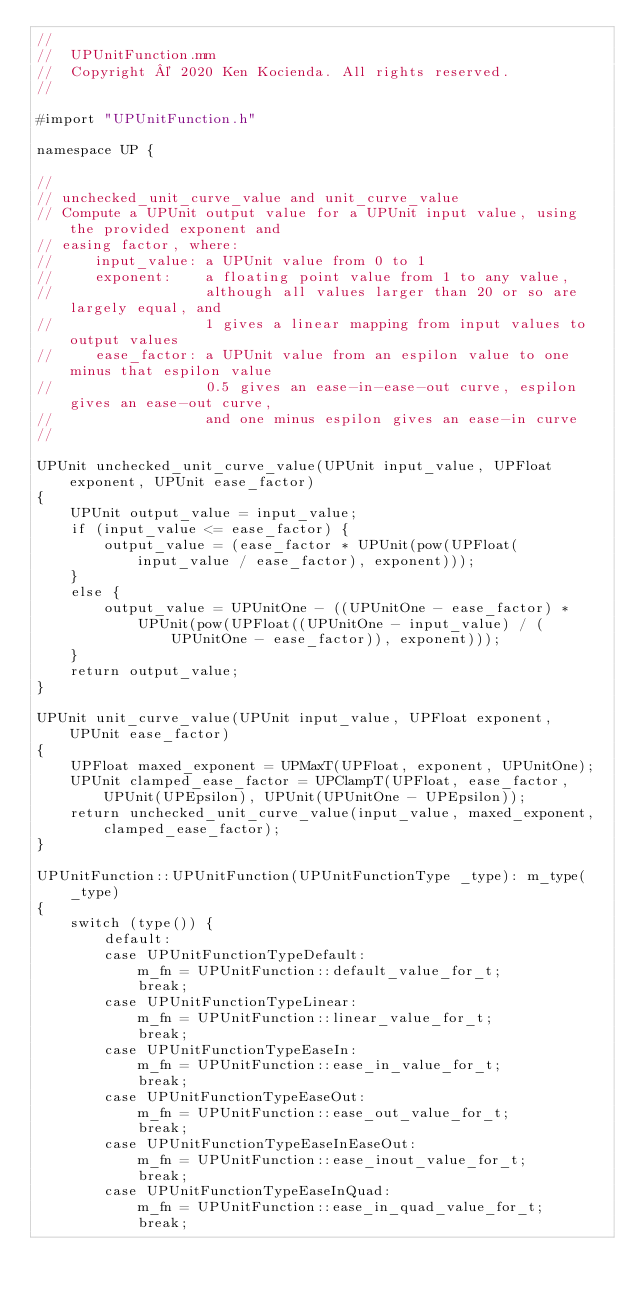Convert code to text. <code><loc_0><loc_0><loc_500><loc_500><_ObjectiveC_>//
//  UPUnitFunction.mm
//  Copyright © 2020 Ken Kocienda. All rights reserved.
//

#import "UPUnitFunction.h"

namespace UP {

//
// unchecked_unit_curve_value and unit_curve_value
// Compute a UPUnit output value for a UPUnit input value, using the provided exponent and
// easing factor, where:
//     input_value: a UPUnit value from 0 to 1
//     exponent:    a floating point value from 1 to any value,
//                  although all values larger than 20 or so are largely equal, and
//                  1 gives a linear mapping from input values to output values
//     ease_factor: a UPUnit value from an espilon value to one minus that espilon value
//                  0.5 gives an ease-in-ease-out curve, espilon gives an ease-out curve,
//                  and one minus espilon gives an ease-in curve
//

UPUnit unchecked_unit_curve_value(UPUnit input_value, UPFloat exponent, UPUnit ease_factor)
{
    UPUnit output_value = input_value;
    if (input_value <= ease_factor) {
        output_value = (ease_factor * UPUnit(pow(UPFloat(input_value / ease_factor), exponent)));
    }
    else {
        output_value = UPUnitOne - ((UPUnitOne - ease_factor) *
            UPUnit(pow(UPFloat((UPUnitOne - input_value) / (UPUnitOne - ease_factor)), exponent)));
    }
    return output_value;
}

UPUnit unit_curve_value(UPUnit input_value, UPFloat exponent, UPUnit ease_factor)
{
    UPFloat maxed_exponent = UPMaxT(UPFloat, exponent, UPUnitOne);
    UPUnit clamped_ease_factor = UPClampT(UPFloat, ease_factor, UPUnit(UPEpsilon), UPUnit(UPUnitOne - UPEpsilon));
    return unchecked_unit_curve_value(input_value, maxed_exponent, clamped_ease_factor);
}

UPUnitFunction::UPUnitFunction(UPUnitFunctionType _type): m_type(_type)
{
    switch (type()) {
        default:
        case UPUnitFunctionTypeDefault:
            m_fn = UPUnitFunction::default_value_for_t;
            break;
        case UPUnitFunctionTypeLinear:
            m_fn = UPUnitFunction::linear_value_for_t;
            break;
        case UPUnitFunctionTypeEaseIn:
            m_fn = UPUnitFunction::ease_in_value_for_t;
            break;
        case UPUnitFunctionTypeEaseOut:
            m_fn = UPUnitFunction::ease_out_value_for_t;
            break;
        case UPUnitFunctionTypeEaseInEaseOut:
            m_fn = UPUnitFunction::ease_inout_value_for_t;
            break;
        case UPUnitFunctionTypeEaseInQuad:
            m_fn = UPUnitFunction::ease_in_quad_value_for_t;
            break;</code> 